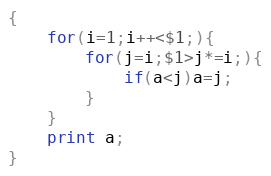Convert code to text. <code><loc_0><loc_0><loc_500><loc_500><_Awk_>{
    for(i=1;i++<$1;){
        for(j=i;$1>j*=i;){
            if(a<j)a=j;
        }
    }
    print a;
}</code> 